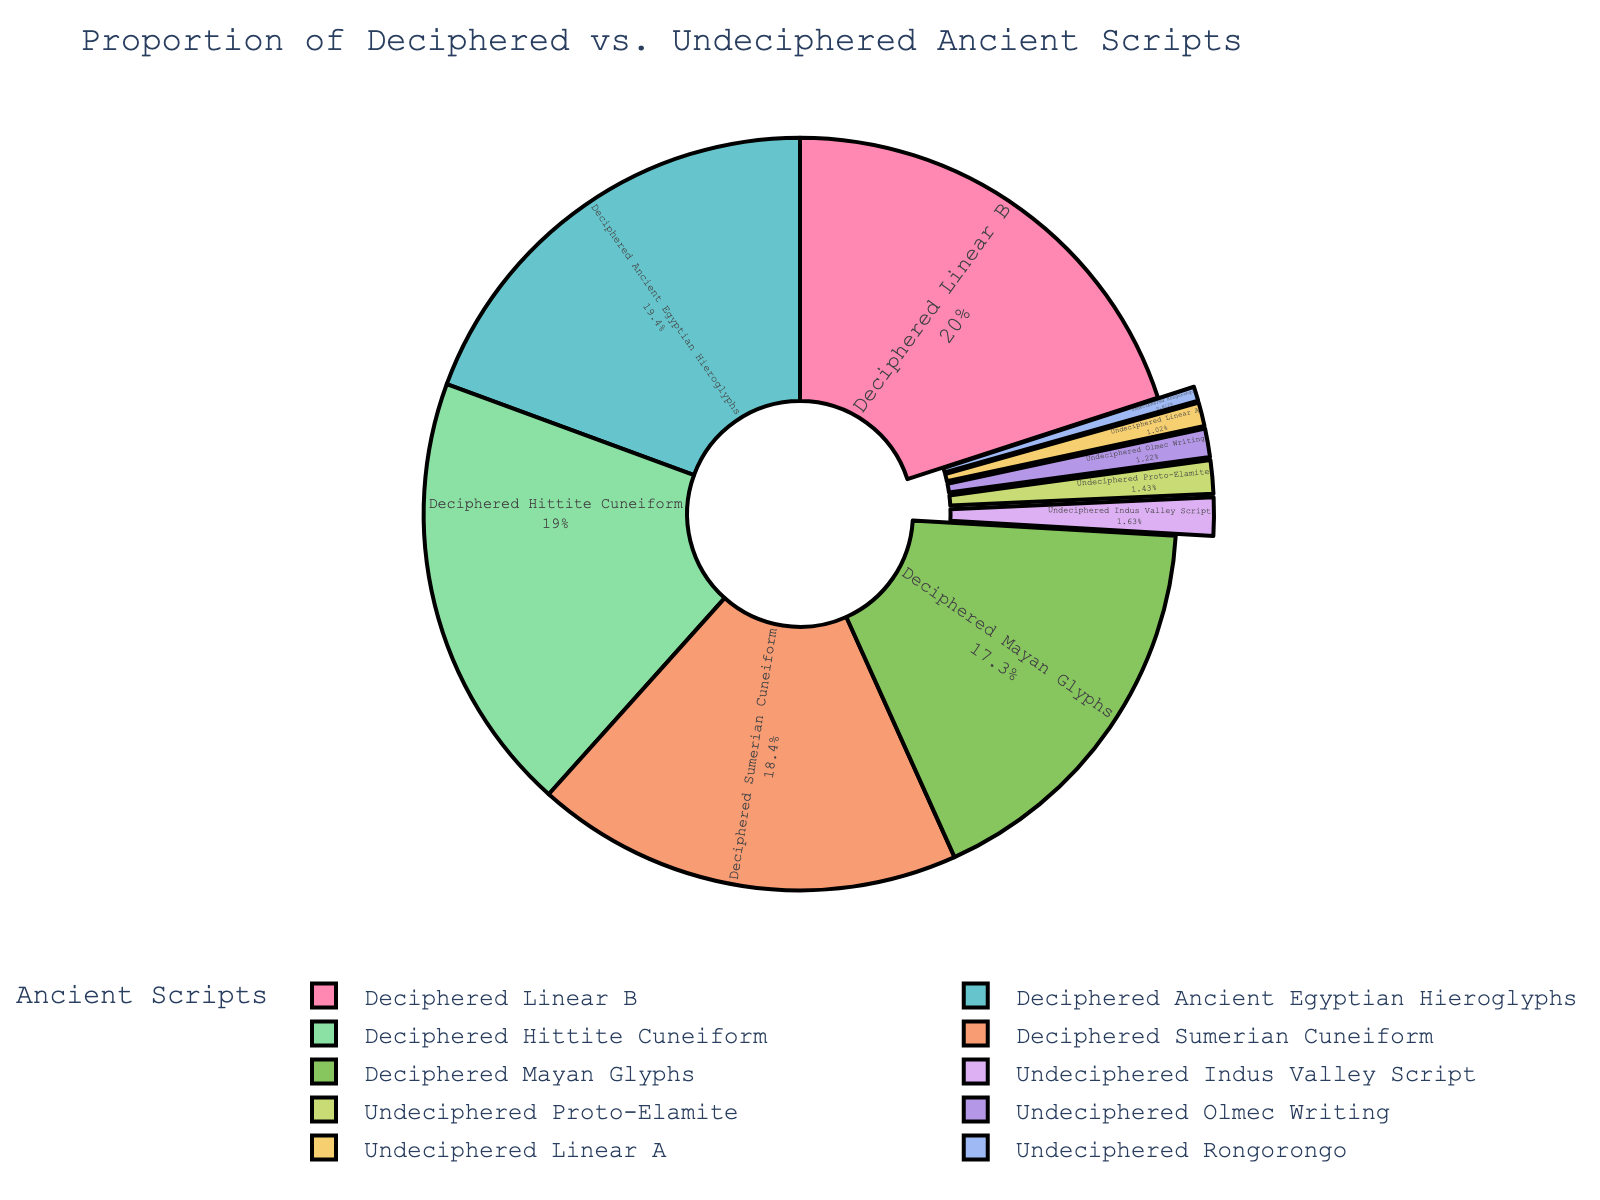Which deciphered script has the highest percentage? Look at the portion of the pie chart to find which deciphered section has the largest piece. Linear B, at 98%, is the largest deciphered portion.
Answer: Linear B Which undeciphered script has the smallest percentage? Identify the smallest segment among the undeciphered sections in the pie chart. Rongorongo, at 3%, is the smallest.
Answer: Rongorongo Comparing all scripts, which deciphered script is second highest in percentage? Exclude the highest deciphered script (Linear B at 98%) and then look for the next largest deciphered portion. That would be Deciphered Ancient Egyptian Hieroglyphs at 95%.
Answer: Deciphered Ancient Egyptian Hieroglyphs What is the average percentage of the deciphered scripts? Calculate the sum of deciphered scripts' percentages and divide by the number of deciphered scripts. Sum = 95 + 90 + 85 + 98 + 93 = 461, Number of scripts = 5, Average = 461 / 5 = 92.2
Answer: 92.2 What is the total percentage of all undeciphered scripts combined? Add the percentages of all undeciphered scripts together. 5 + 8 + 3 + 7 + 6 = 29
Answer: 29 Which has a greater percentage: undeciphered Indus Valley Script or deciphered Hittite Cuneiform? Compare the two percentages directly: Indus Valley Script is 8%, Hittite Cuneiform is 93%.
Answer: Deciphered Hittite Cuneiform What is the difference in percentage between deciphered Mayan Glyphs and undeciphered Proto-Elamite? Subtract the undeciphered Proto-Elamite percentage from the deciphered Mayan Glyphs percentage: 85 - 7 = 78
Answer: 78 How much more percentage does deciphered Sumerian Cuneiform have than undeciphered Olmec Writing? Calculate the difference by subtracting undeciphered Olmec Writing percentage from deciphered Sumerian Cuneiform: 90 - 6 = 84
Answer: 84 